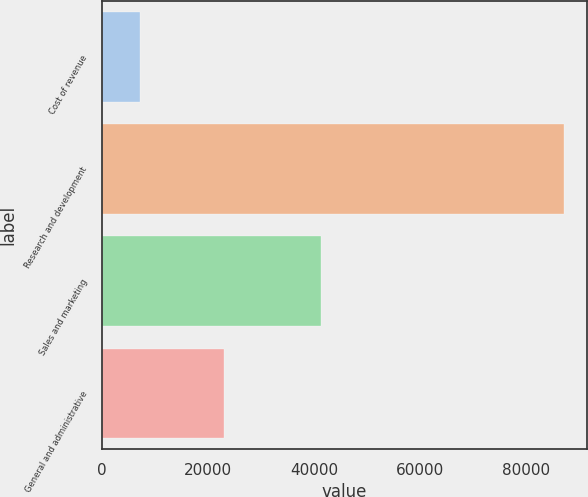Convert chart. <chart><loc_0><loc_0><loc_500><loc_500><bar_chart><fcel>Cost of revenue<fcel>Research and development<fcel>Sales and marketing<fcel>General and administrative<nl><fcel>7165<fcel>87163<fcel>41227<fcel>22972<nl></chart> 